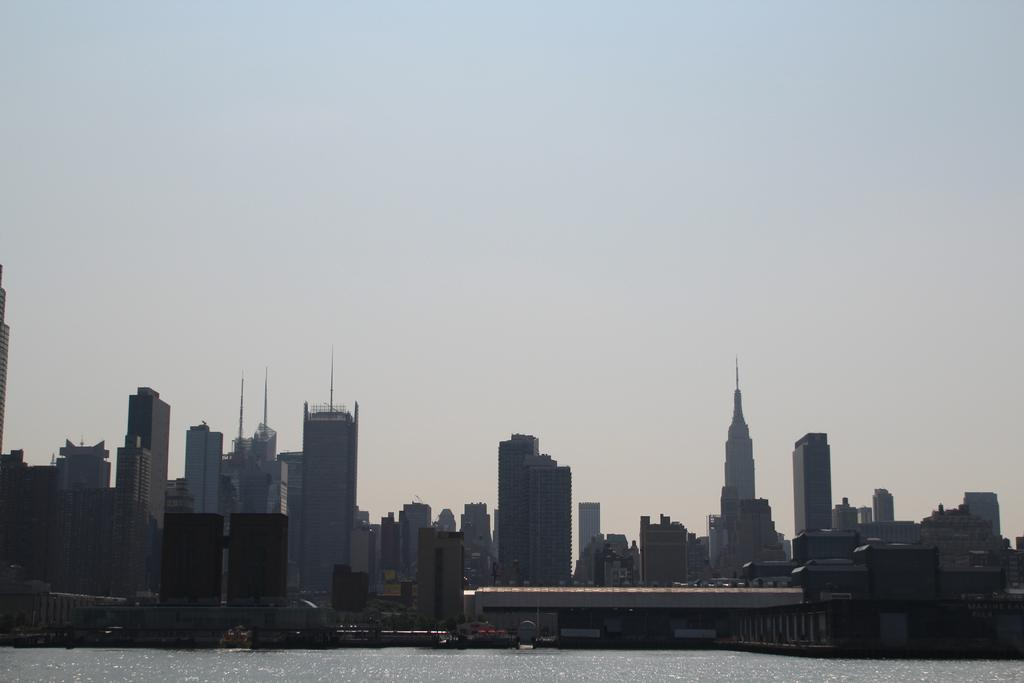What type of structures can be seen in the image? There are buildings in the image. What natural feature is present in the image? There is a river in the image. What can be seen in the background of the image? The sky is visible in the background of the image. What type of scent can be detected from the river in the image? There is no information about the scent of the river in the image, as it only provides visual information. How is the distribution of the buildings in the image? The distribution of the buildings cannot be determined from the image alone, as it only shows a portion of the area. 